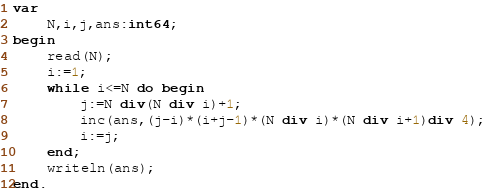<code> <loc_0><loc_0><loc_500><loc_500><_Pascal_>var
	N,i,j,ans:int64;
begin
	read(N);
	i:=1;
	while i<=N do begin
		j:=N div(N div i)+1;
		inc(ans,(j-i)*(i+j-1)*(N div i)*(N div i+1)div 4);
		i:=j;
	end;
	writeln(ans);
end.</code> 